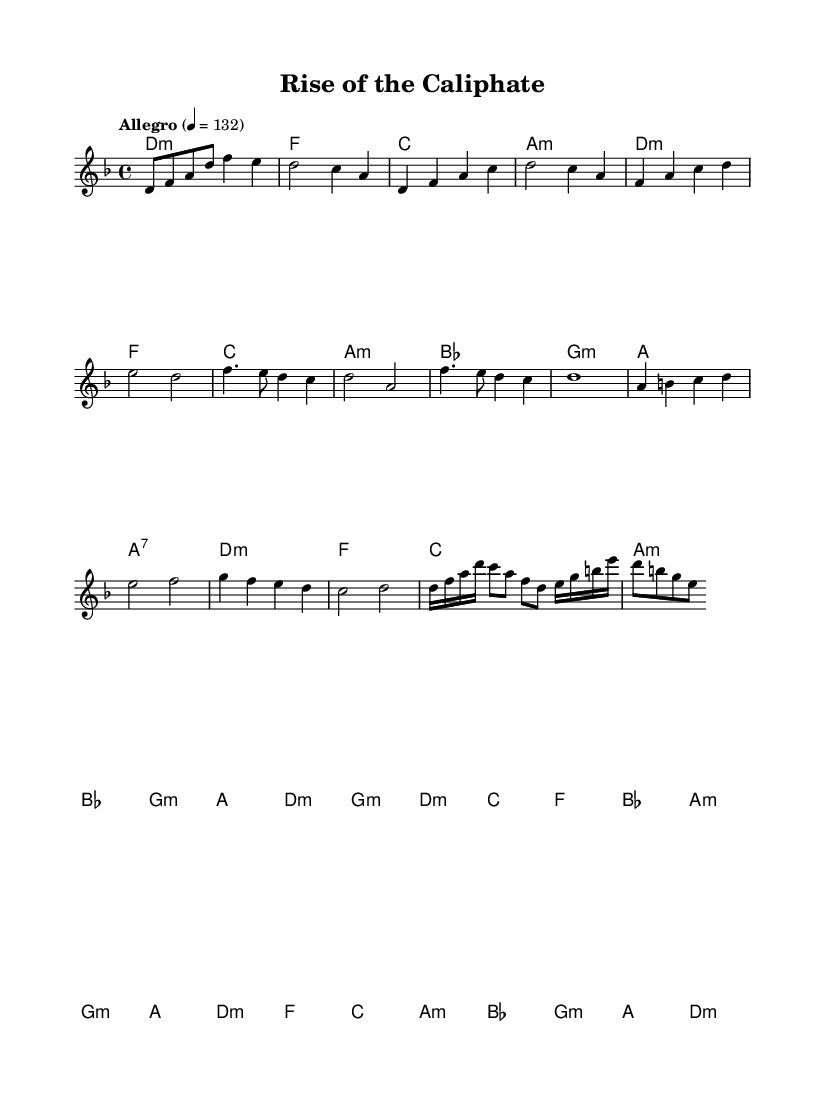What is the key signature of this music? The key signature indicated is D minor, which includes one flat (B flat).
Answer: D minor What is the time signature of this music? The time signature is indicated as 4/4, which means four beats per measure and a quarter note receives one beat.
Answer: 4/4 What is the tempo marking for this piece? The tempo marking is "Allegro," set at a quarter note equals 132 beats per minute, indicating a fast and lively pace.
Answer: Allegro How many measures are there in the chorus section? By counting the measures labeled in the music's chorus section, we find that there are four measures.
Answer: 4 Which section has a more complex rhythm, the verse or the solo? The solo section features sixteenth notes and a more varied rhythm compared to the verse, which has more quarter notes. The increased rhythmic activity indicates complexity in the solo.
Answer: Solo Identify the first chord of the bridge section. The bridge section begins with the chord G minor, which is the first chord notated at the start of that section.
Answer: G minor How does the harmony change between the verse and the chorus? The verse uses a progression that includes A minor and G minor, while the chorus features a straightforward progression with B flat and A major, indicating a shift towards a brighter tonality.
Answer: A minor to B flat 